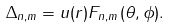Convert formula to latex. <formula><loc_0><loc_0><loc_500><loc_500>\Delta _ { n , m } = u ( r ) F _ { n , m } ( \theta , \phi ) .</formula> 